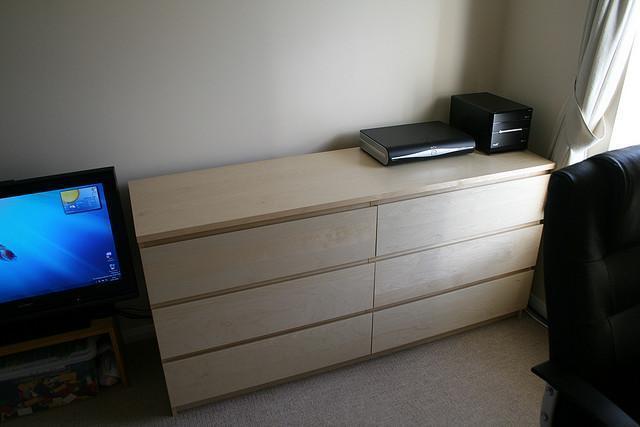How many drawers in the dresser?
Give a very brief answer. 6. 